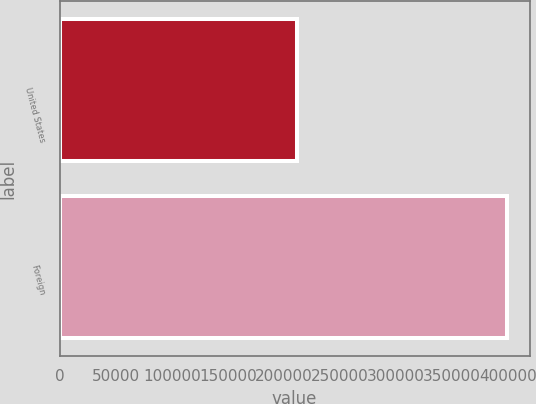<chart> <loc_0><loc_0><loc_500><loc_500><bar_chart><fcel>United States<fcel>Foreign<nl><fcel>211588<fcel>399301<nl></chart> 